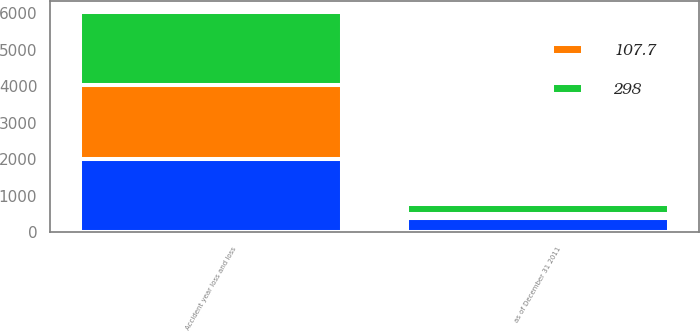Convert chart to OTSL. <chart><loc_0><loc_0><loc_500><loc_500><stacked_bar_chart><ecel><fcel>Accident year loss and loss<fcel>as of December 31 2011<nl><fcel>nan<fcel>2011<fcel>389<nl><fcel>298<fcel>2009<fcel>289<nl><fcel>107.7<fcel>2009<fcel>104.7<nl></chart> 